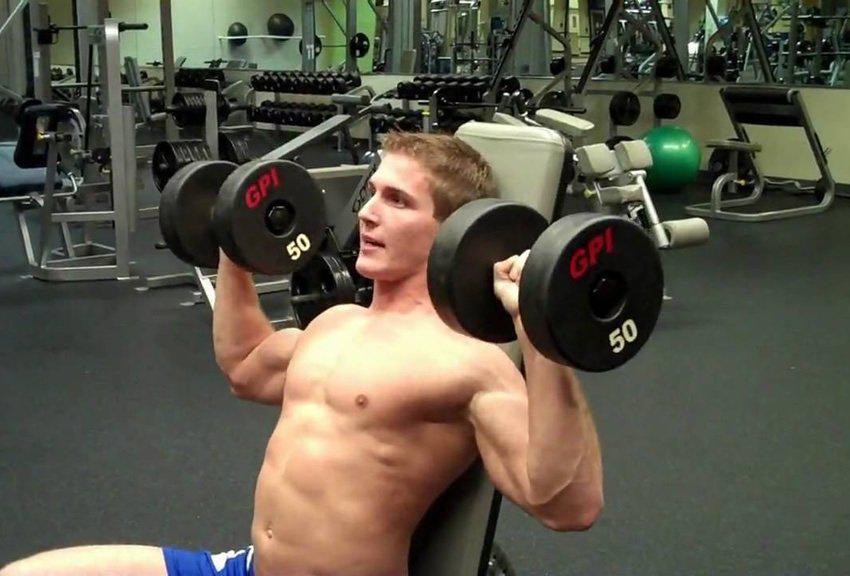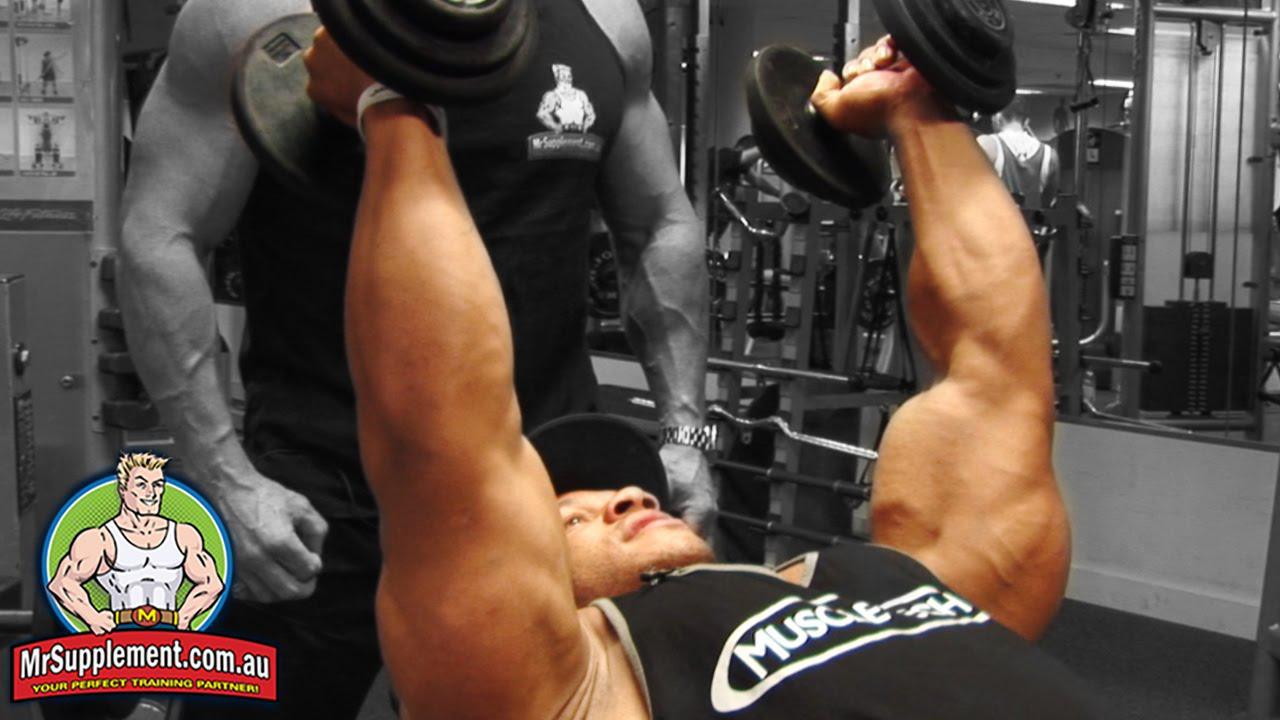The first image is the image on the left, the second image is the image on the right. For the images displayed, is the sentence "At least one image features a woman." factually correct? Answer yes or no. No. 